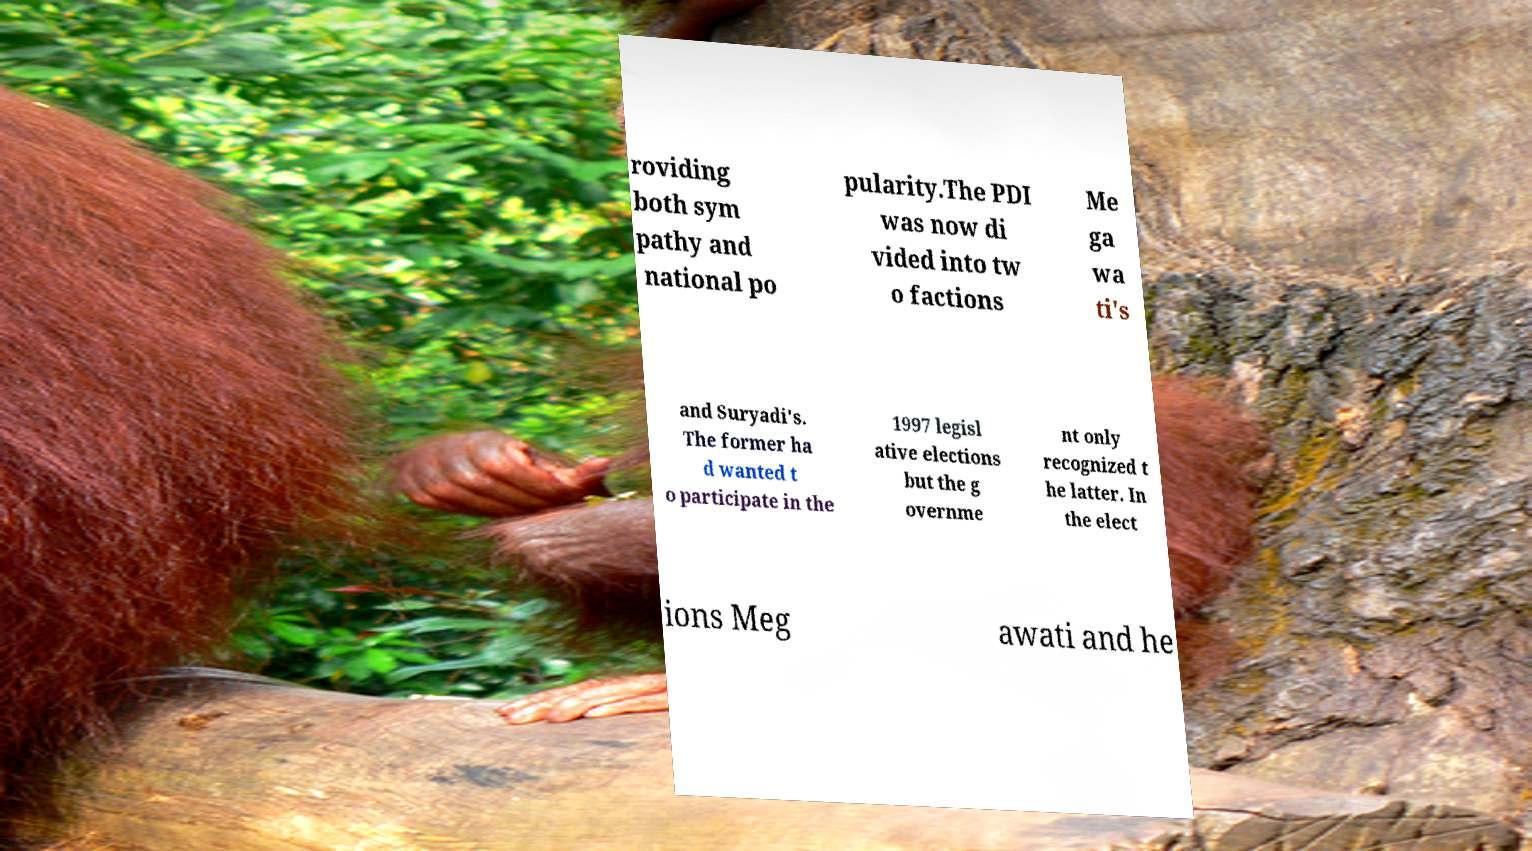Could you extract and type out the text from this image? roviding both sym pathy and national po pularity.The PDI was now di vided into tw o factions Me ga wa ti's and Suryadi's. The former ha d wanted t o participate in the 1997 legisl ative elections but the g overnme nt only recognized t he latter. In the elect ions Meg awati and he 